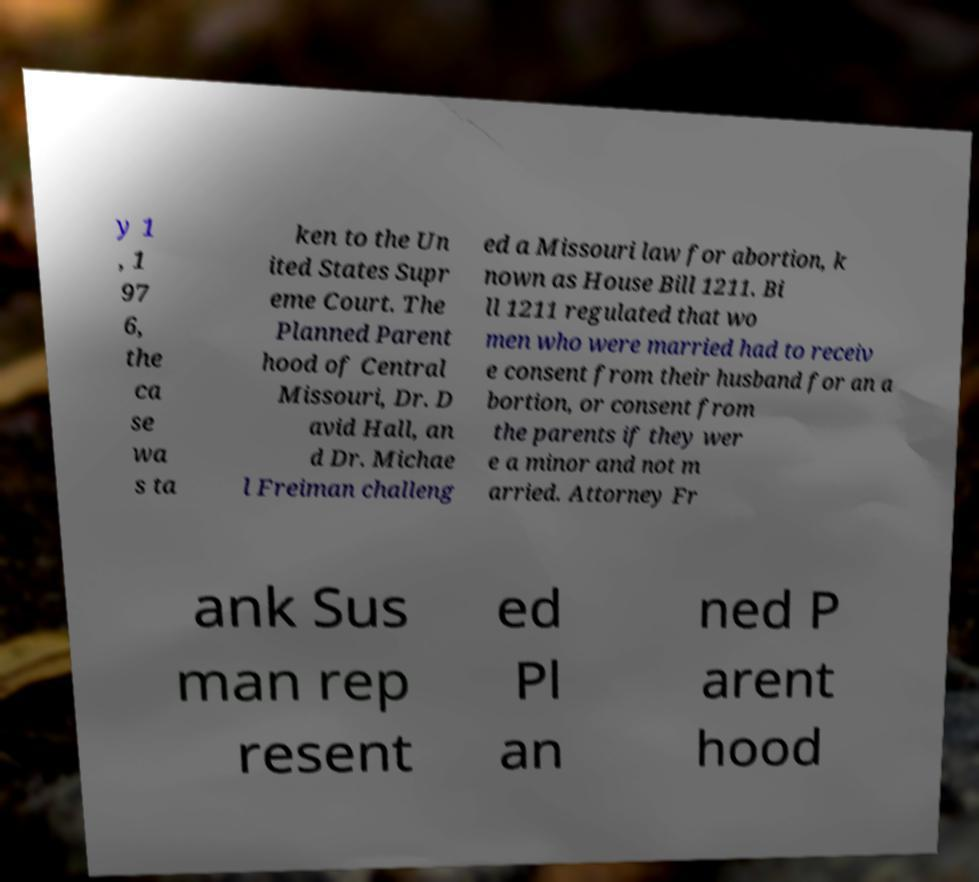Please read and relay the text visible in this image. What does it say? y 1 , 1 97 6, the ca se wa s ta ken to the Un ited States Supr eme Court. The Planned Parent hood of Central Missouri, Dr. D avid Hall, an d Dr. Michae l Freiman challeng ed a Missouri law for abortion, k nown as House Bill 1211. Bi ll 1211 regulated that wo men who were married had to receiv e consent from their husband for an a bortion, or consent from the parents if they wer e a minor and not m arried. Attorney Fr ank Sus man rep resent ed Pl an ned P arent hood 